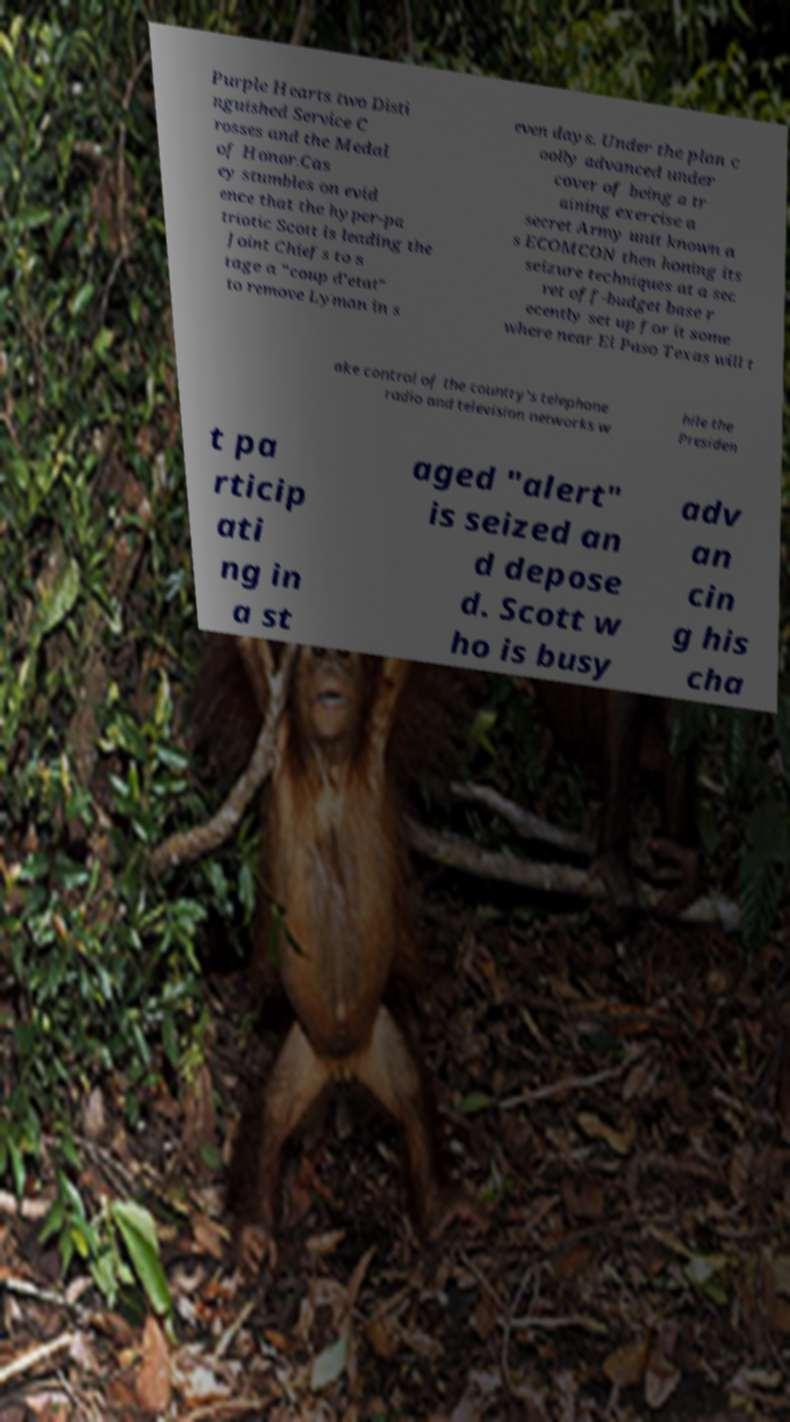What messages or text are displayed in this image? I need them in a readable, typed format. Purple Hearts two Disti nguished Service C rosses and the Medal of Honor.Cas ey stumbles on evid ence that the hyper-pa triotic Scott is leading the Joint Chiefs to s tage a "coup d'etat" to remove Lyman in s even days. Under the plan c oolly advanced under cover of being a tr aining exercise a secret Army unit known a s ECOMCON then honing its seizure techniques at a sec ret off-budget base r ecently set up for it some where near El Paso Texas will t ake control of the country's telephone radio and television networks w hile the Presiden t pa rticip ati ng in a st aged "alert" is seized an d depose d. Scott w ho is busy adv an cin g his cha 